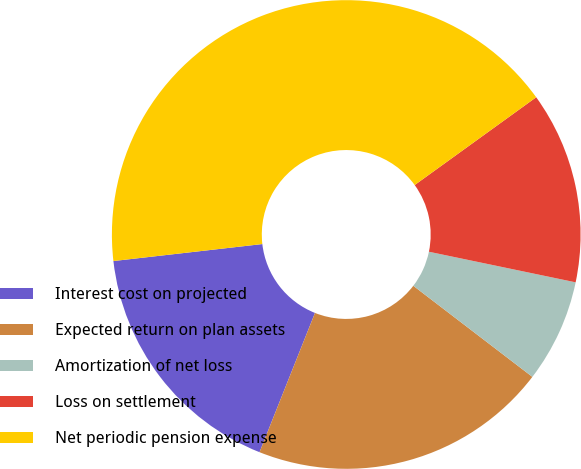<chart> <loc_0><loc_0><loc_500><loc_500><pie_chart><fcel>Interest cost on projected<fcel>Expected return on plan assets<fcel>Amortization of net loss<fcel>Loss on settlement<fcel>Net periodic pension expense<nl><fcel>17.16%<fcel>20.64%<fcel>7.12%<fcel>13.23%<fcel>41.85%<nl></chart> 